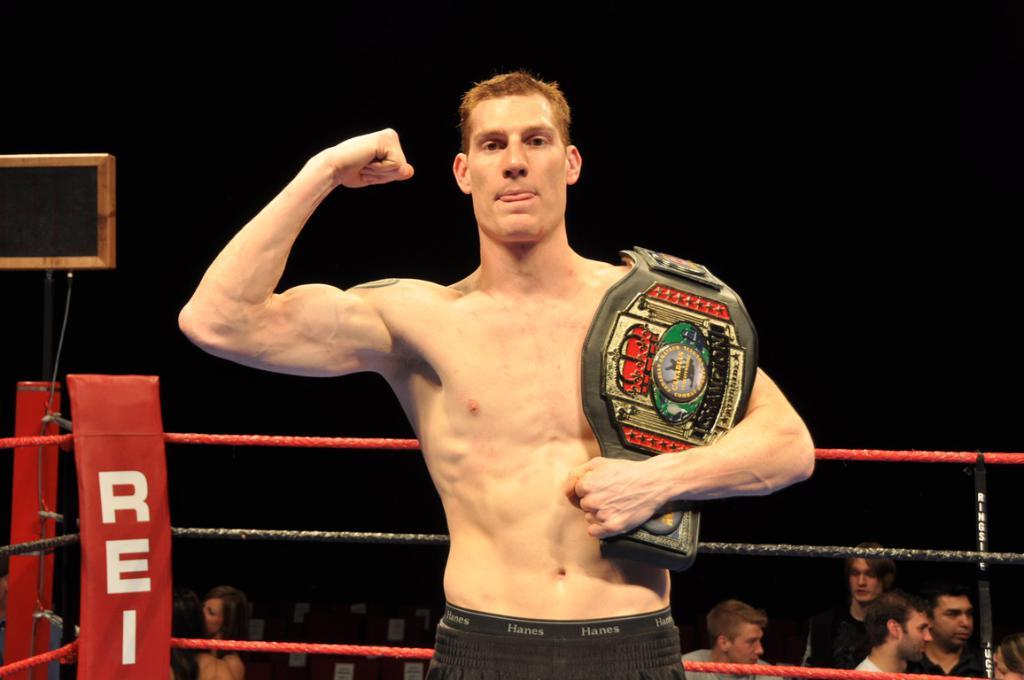Provide a one-sentence caption for the provided image. A man proudly holds a wrestling belt inside of a red ring that says REI on it. 